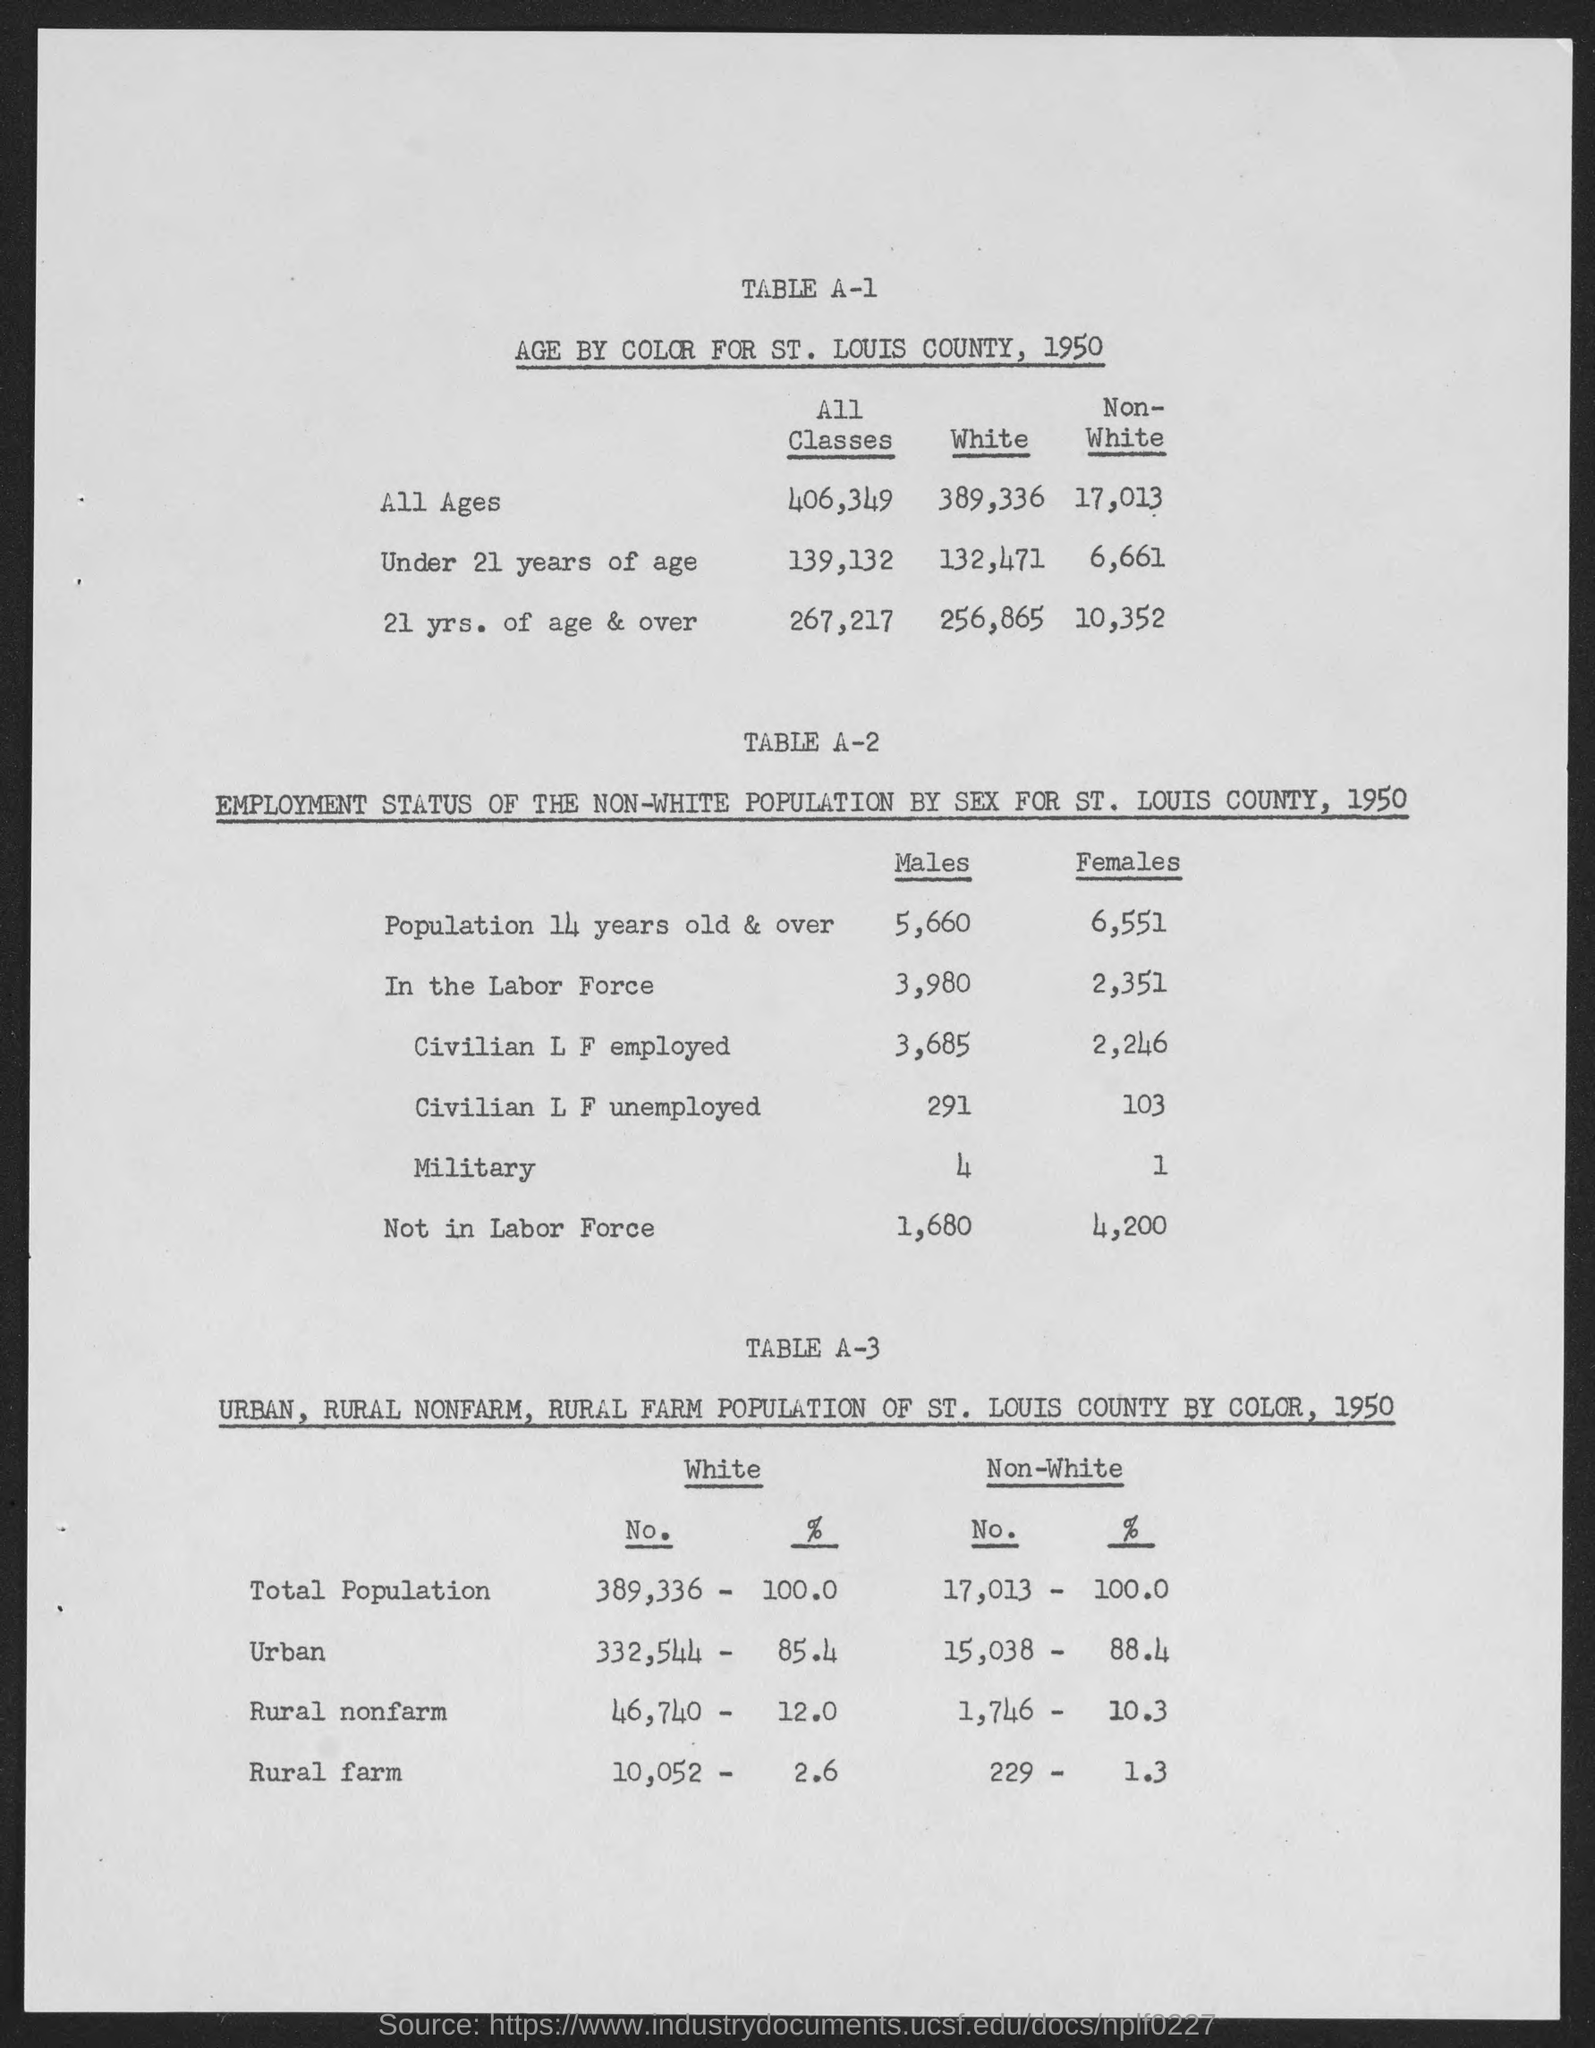How did the urban and rural populations differ by color in St. Louis county, 1950? In 1950, the urban population in St. Louis County for individuals identified as White was 332,544, which was 85.4% of the total White population. For Non-White individuals, 15,038 lived in urban areas, making up 88.4% of the total Non-White population. Rural nonfarm populations were 12.0% for White individuals and 10.3% for Non-White individuals, while rural farm populations were 2.6% for White and 1.3% for Non-White individuals. 